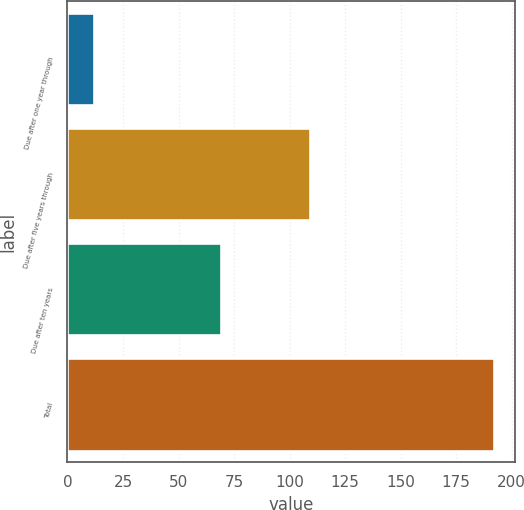<chart> <loc_0><loc_0><loc_500><loc_500><bar_chart><fcel>Due after one year through<fcel>Due after five years through<fcel>Due after ten years<fcel>Total<nl><fcel>12<fcel>109<fcel>69<fcel>192<nl></chart> 